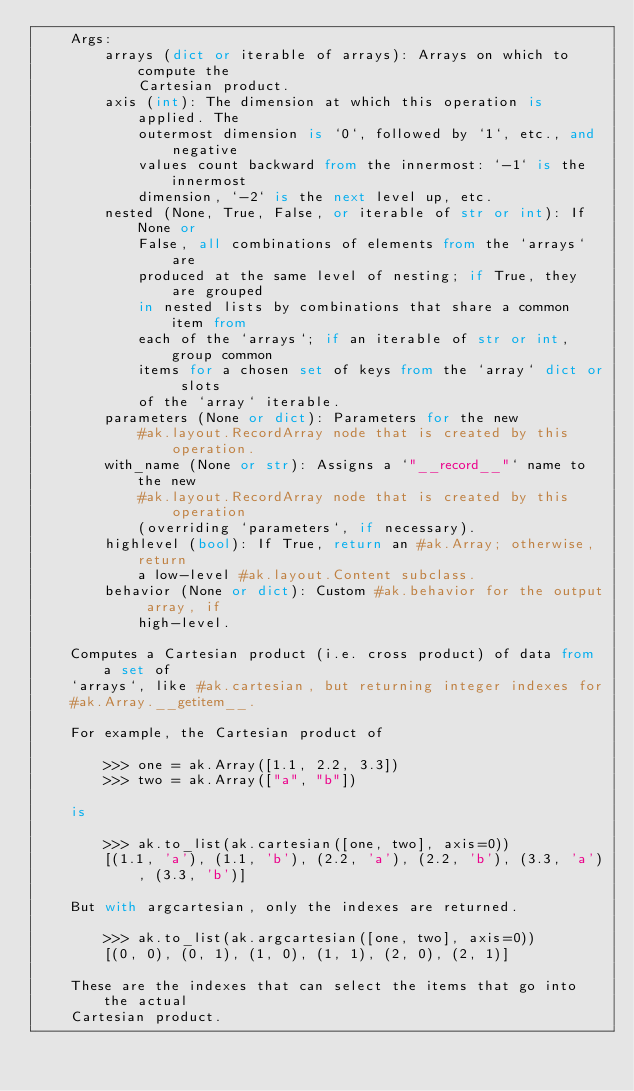Convert code to text. <code><loc_0><loc_0><loc_500><loc_500><_Python_>    Args:
        arrays (dict or iterable of arrays): Arrays on which to compute the
            Cartesian product.
        axis (int): The dimension at which this operation is applied. The
            outermost dimension is `0`, followed by `1`, etc., and negative
            values count backward from the innermost: `-1` is the innermost
            dimension, `-2` is the next level up, etc.
        nested (None, True, False, or iterable of str or int): If None or
            False, all combinations of elements from the `arrays` are
            produced at the same level of nesting; if True, they are grouped
            in nested lists by combinations that share a common item from
            each of the `arrays`; if an iterable of str or int, group common
            items for a chosen set of keys from the `array` dict or slots
            of the `array` iterable.
        parameters (None or dict): Parameters for the new
            #ak.layout.RecordArray node that is created by this operation.
        with_name (None or str): Assigns a `"__record__"` name to the new
            #ak.layout.RecordArray node that is created by this operation
            (overriding `parameters`, if necessary).
        highlevel (bool): If True, return an #ak.Array; otherwise, return
            a low-level #ak.layout.Content subclass.
        behavior (None or dict): Custom #ak.behavior for the output array, if
            high-level.

    Computes a Cartesian product (i.e. cross product) of data from a set of
    `arrays`, like #ak.cartesian, but returning integer indexes for
    #ak.Array.__getitem__.

    For example, the Cartesian product of

        >>> one = ak.Array([1.1, 2.2, 3.3])
        >>> two = ak.Array(["a", "b"])

    is

        >>> ak.to_list(ak.cartesian([one, two], axis=0))
        [(1.1, 'a'), (1.1, 'b'), (2.2, 'a'), (2.2, 'b'), (3.3, 'a'), (3.3, 'b')]

    But with argcartesian, only the indexes are returned.

        >>> ak.to_list(ak.argcartesian([one, two], axis=0))
        [(0, 0), (0, 1), (1, 0), (1, 1), (2, 0), (2, 1)]

    These are the indexes that can select the items that go into the actual
    Cartesian product.
</code> 